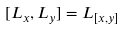Convert formula to latex. <formula><loc_0><loc_0><loc_500><loc_500>[ L _ { x } , L _ { y } ] = L _ { [ x , y ] }</formula> 